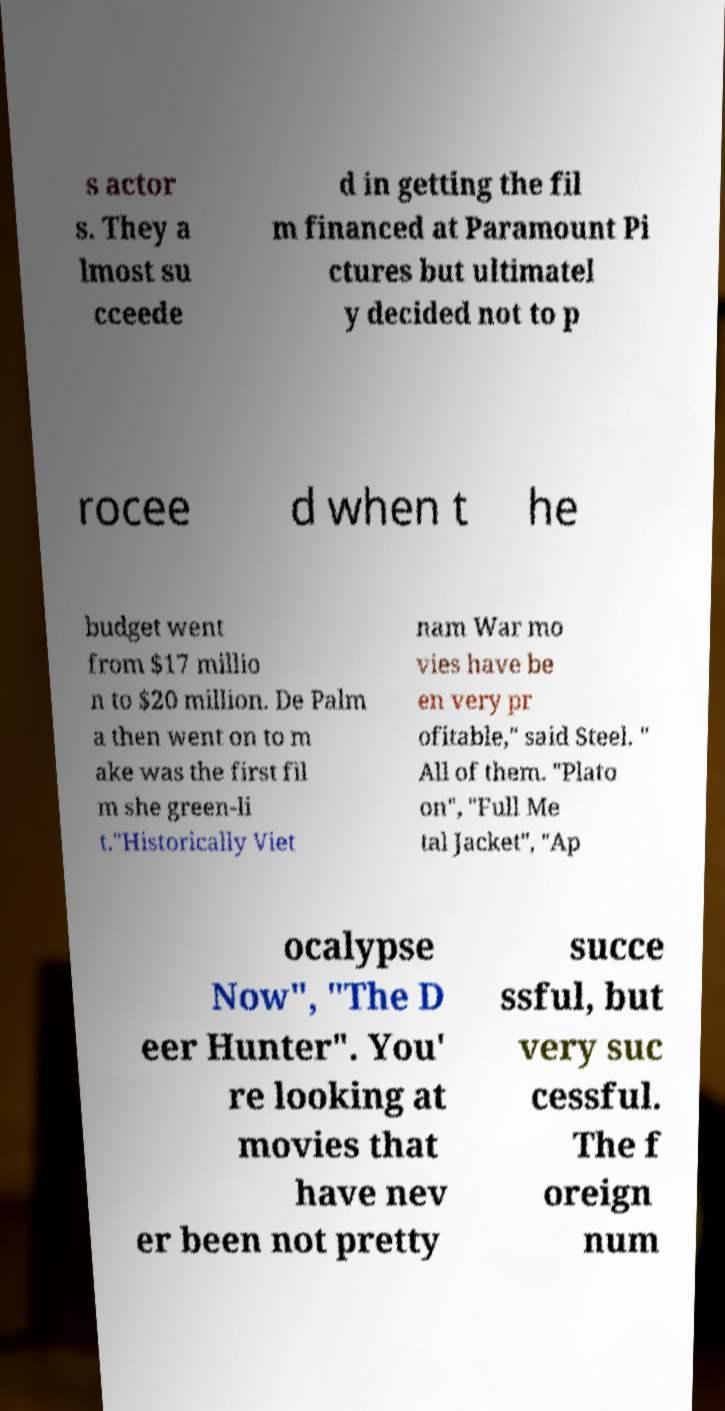Can you read and provide the text displayed in the image?This photo seems to have some interesting text. Can you extract and type it out for me? s actor s. They a lmost su cceede d in getting the fil m financed at Paramount Pi ctures but ultimatel y decided not to p rocee d when t he budget went from $17 millio n to $20 million. De Palm a then went on to m ake was the first fil m she green-li t."Historically Viet nam War mo vies have be en very pr ofitable," said Steel. " All of them. "Plato on", "Full Me tal Jacket", "Ap ocalypse Now", "The D eer Hunter". You' re looking at movies that have nev er been not pretty succe ssful, but very suc cessful. The f oreign num 